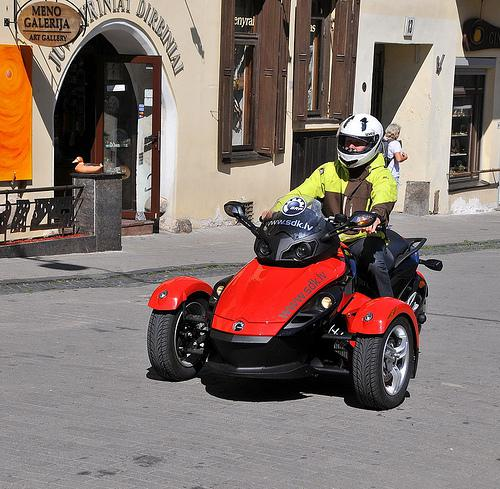Question: what is he doing?
Choices:
A. Driving.
B. Operating a vehicle.
C. Biking.
D. Running.
Answer with the letter. Answer: A Question: where is the image taken?
Choices:
A. In the city.
B. At a building.
C. On road.
D. Rush hour.
Answer with the letter. Answer: C Question: who is in the image?
Choices:
A. A dog.
B. Person.
C. A building.
D. Three people.
Answer with the letter. Answer: B Question: why is the purpose of helmet?
Choices:
A. Protection.
B. To be safe.
C. Cover.
D. Decoration.
Answer with the letter. Answer: B 